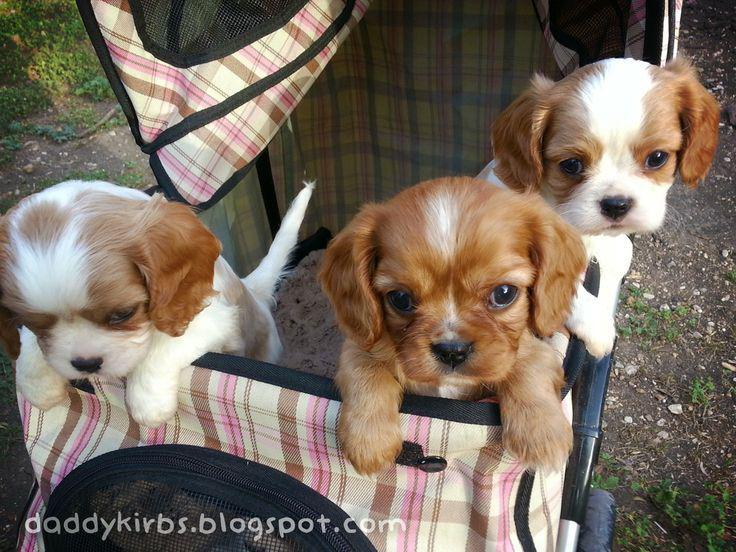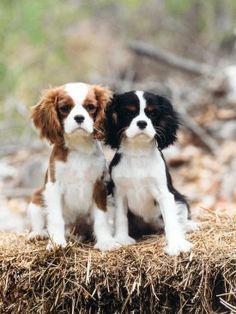The first image is the image on the left, the second image is the image on the right. Considering the images on both sides, is "In the left image, there is no less than two dogs in a woven basket, and in the right image there is a single brown and white dog" valid? Answer yes or no. No. The first image is the image on the left, the second image is the image on the right. For the images displayed, is the sentence "The left image contains at least three dogs." factually correct? Answer yes or no. Yes. 